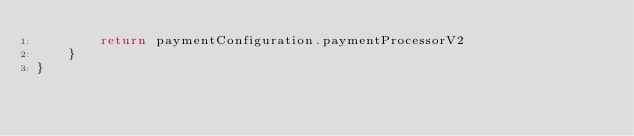Convert code to text. <code><loc_0><loc_0><loc_500><loc_500><_Kotlin_>        return paymentConfiguration.paymentProcessorV2
    }
}</code> 